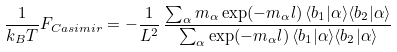<formula> <loc_0><loc_0><loc_500><loc_500>\frac { 1 } { k _ { B } T } F _ { C a s i m i r } = - \frac { 1 } { L ^ { 2 } } \, \frac { \sum _ { \alpha } m _ { \alpha } \exp ( - m _ { \alpha } l ) \, \langle b _ { 1 } | \alpha \rangle \langle b _ { 2 } | \alpha \rangle } { \sum _ { \alpha } \exp ( - m _ { \alpha } l ) \, \langle b _ { 1 } | \alpha \rangle \langle b _ { 2 } | \alpha \rangle }</formula> 